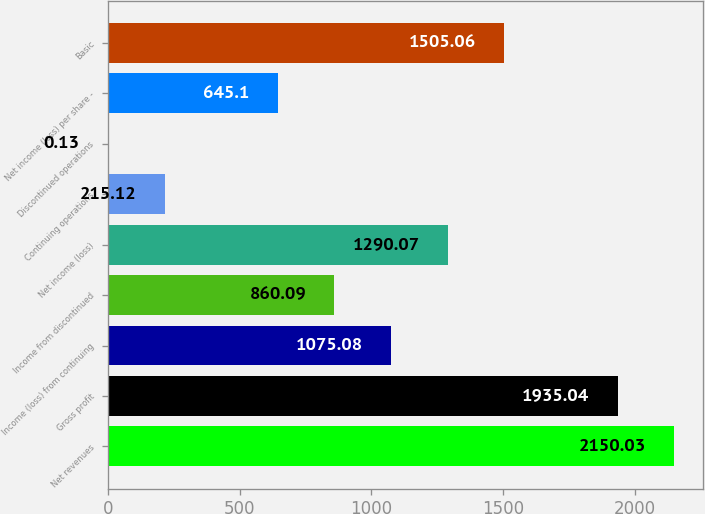Convert chart to OTSL. <chart><loc_0><loc_0><loc_500><loc_500><bar_chart><fcel>Net revenues<fcel>Gross profit<fcel>Income (loss) from continuing<fcel>Income from discontinued<fcel>Net income (loss)<fcel>Continuing operations<fcel>Discontinued operations<fcel>Net income (loss) per share -<fcel>Basic<nl><fcel>2150.03<fcel>1935.04<fcel>1075.08<fcel>860.09<fcel>1290.07<fcel>215.12<fcel>0.13<fcel>645.1<fcel>1505.06<nl></chart> 